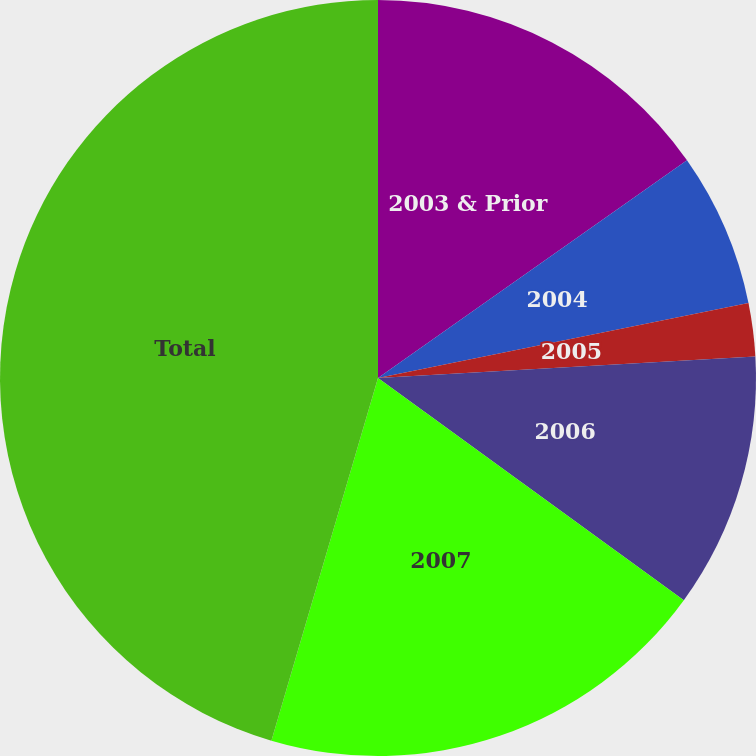Convert chart to OTSL. <chart><loc_0><loc_0><loc_500><loc_500><pie_chart><fcel>2003 & Prior<fcel>2004<fcel>2005<fcel>2006<fcel>2007<fcel>Total<nl><fcel>15.23%<fcel>6.59%<fcel>2.27%<fcel>10.91%<fcel>19.55%<fcel>45.45%<nl></chart> 